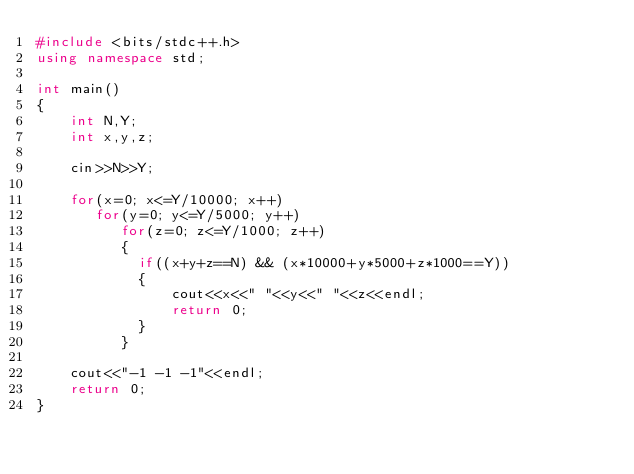<code> <loc_0><loc_0><loc_500><loc_500><_C++_>#include <bits/stdc++.h>
using namespace std;

int main()
{
	int N,Y;
	int x,y,z;
	
	cin>>N>>Y;
	
	for(x=0; x<=Y/10000; x++)
	   for(y=0; y<=Y/5000; y++)
	      for(z=0; z<=Y/1000; z++)
		  {
		  	if((x+y+z==N) && (x*10000+y*5000+z*1000==Y))
		  	{
		  		cout<<x<<" "<<y<<" "<<z<<endl;
		  		return 0;
		  	}
		  }
		  
	cout<<"-1 -1 -1"<<endl;
	return 0;
}</code> 